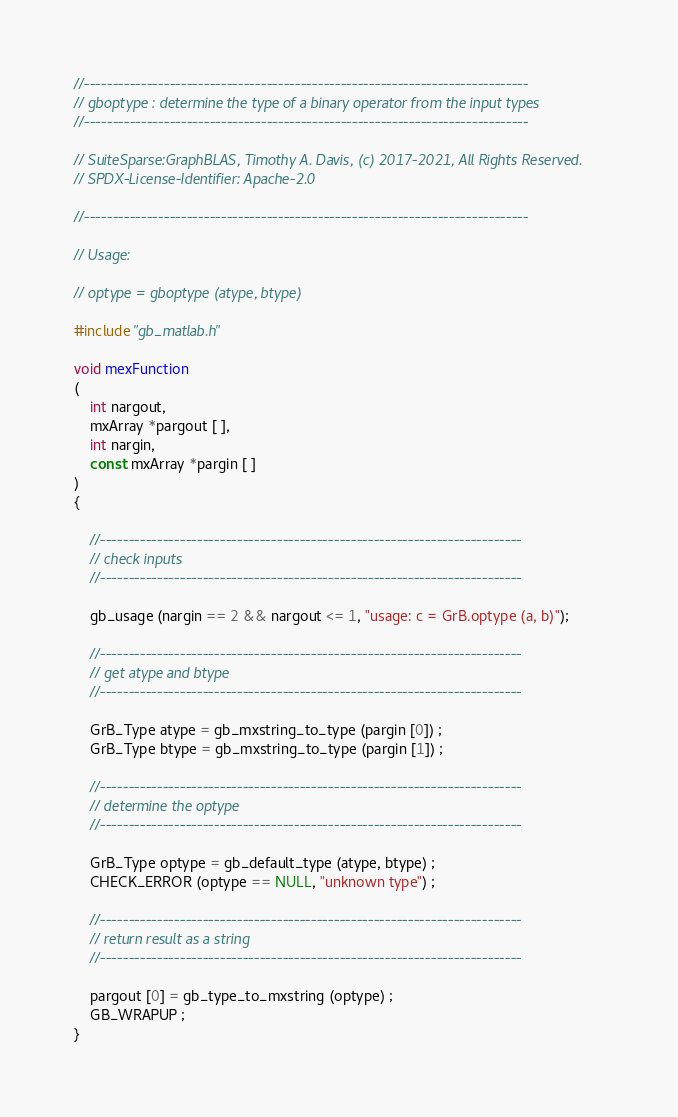<code> <loc_0><loc_0><loc_500><loc_500><_C_>//------------------------------------------------------------------------------
// gboptype : determine the type of a binary operator from the input types
//------------------------------------------------------------------------------

// SuiteSparse:GraphBLAS, Timothy A. Davis, (c) 2017-2021, All Rights Reserved.
// SPDX-License-Identifier: Apache-2.0

//------------------------------------------------------------------------------

// Usage:

// optype = gboptype (atype, btype)

#include "gb_matlab.h"

void mexFunction
(
    int nargout,
    mxArray *pargout [ ],
    int nargin,
    const mxArray *pargin [ ]
)
{

    //--------------------------------------------------------------------------
    // check inputs
    //--------------------------------------------------------------------------

    gb_usage (nargin == 2 && nargout <= 1, "usage: c = GrB.optype (a, b)");

    //--------------------------------------------------------------------------
    // get atype and btype
    //--------------------------------------------------------------------------

    GrB_Type atype = gb_mxstring_to_type (pargin [0]) ;
    GrB_Type btype = gb_mxstring_to_type (pargin [1]) ;

    //--------------------------------------------------------------------------
    // determine the optype
    //--------------------------------------------------------------------------

    GrB_Type optype = gb_default_type (atype, btype) ;
    CHECK_ERROR (optype == NULL, "unknown type") ;

    //--------------------------------------------------------------------------
    // return result as a string
    //--------------------------------------------------------------------------

    pargout [0] = gb_type_to_mxstring (optype) ;
    GB_WRAPUP ;
}

</code> 